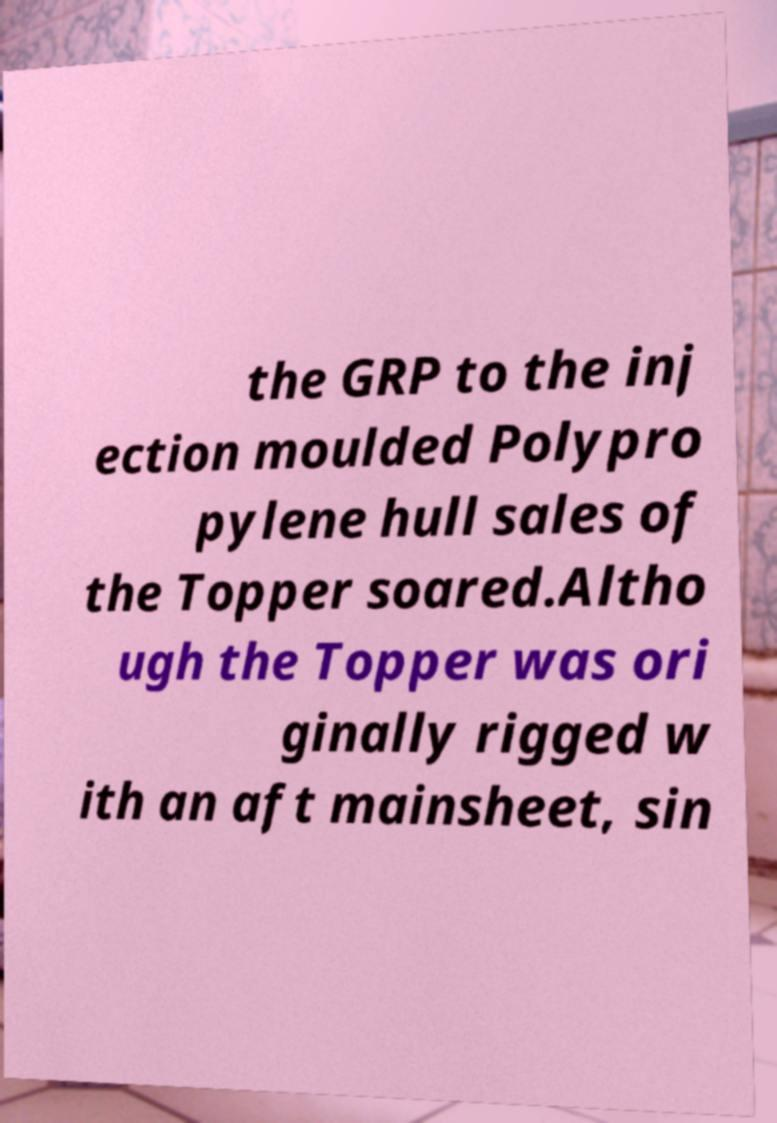Could you assist in decoding the text presented in this image and type it out clearly? the GRP to the inj ection moulded Polypro pylene hull sales of the Topper soared.Altho ugh the Topper was ori ginally rigged w ith an aft mainsheet, sin 